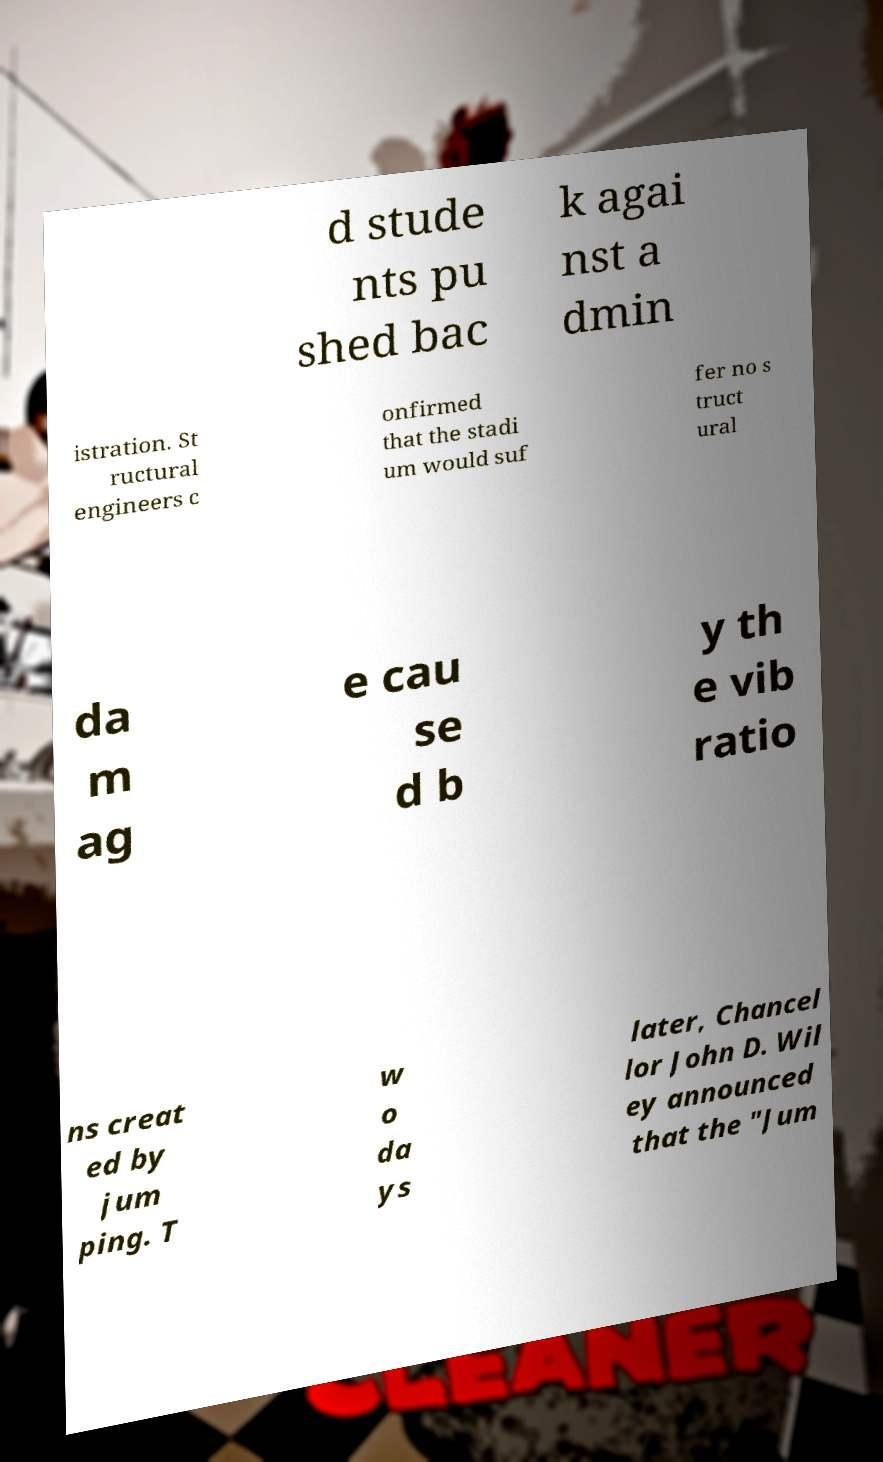What messages or text are displayed in this image? I need them in a readable, typed format. d stude nts pu shed bac k agai nst a dmin istration. St ructural engineers c onfirmed that the stadi um would suf fer no s truct ural da m ag e cau se d b y th e vib ratio ns creat ed by jum ping. T w o da ys later, Chancel lor John D. Wil ey announced that the "Jum 